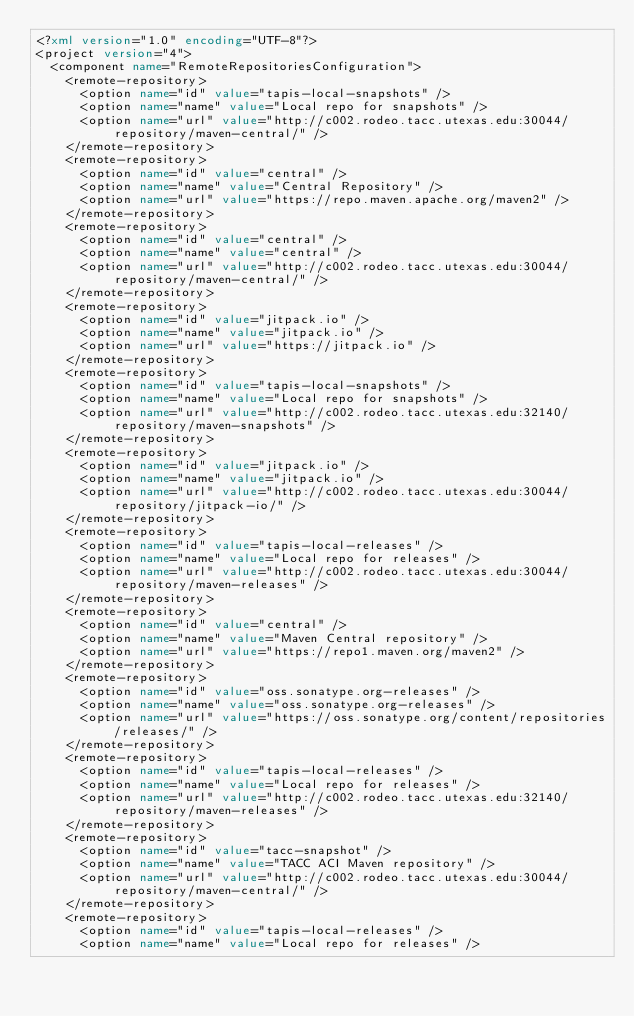Convert code to text. <code><loc_0><loc_0><loc_500><loc_500><_XML_><?xml version="1.0" encoding="UTF-8"?>
<project version="4">
  <component name="RemoteRepositoriesConfiguration">
    <remote-repository>
      <option name="id" value="tapis-local-snapshots" />
      <option name="name" value="Local repo for snapshots" />
      <option name="url" value="http://c002.rodeo.tacc.utexas.edu:30044/repository/maven-central/" />
    </remote-repository>
    <remote-repository>
      <option name="id" value="central" />
      <option name="name" value="Central Repository" />
      <option name="url" value="https://repo.maven.apache.org/maven2" />
    </remote-repository>
    <remote-repository>
      <option name="id" value="central" />
      <option name="name" value="central" />
      <option name="url" value="http://c002.rodeo.tacc.utexas.edu:30044/repository/maven-central/" />
    </remote-repository>
    <remote-repository>
      <option name="id" value="jitpack.io" />
      <option name="name" value="jitpack.io" />
      <option name="url" value="https://jitpack.io" />
    </remote-repository>
    <remote-repository>
      <option name="id" value="tapis-local-snapshots" />
      <option name="name" value="Local repo for snapshots" />
      <option name="url" value="http://c002.rodeo.tacc.utexas.edu:32140/repository/maven-snapshots" />
    </remote-repository>
    <remote-repository>
      <option name="id" value="jitpack.io" />
      <option name="name" value="jitpack.io" />
      <option name="url" value="http://c002.rodeo.tacc.utexas.edu:30044/repository/jitpack-io/" />
    </remote-repository>
    <remote-repository>
      <option name="id" value="tapis-local-releases" />
      <option name="name" value="Local repo for releases" />
      <option name="url" value="http://c002.rodeo.tacc.utexas.edu:30044/repository/maven-releases" />
    </remote-repository>
    <remote-repository>
      <option name="id" value="central" />
      <option name="name" value="Maven Central repository" />
      <option name="url" value="https://repo1.maven.org/maven2" />
    </remote-repository>
    <remote-repository>
      <option name="id" value="oss.sonatype.org-releases" />
      <option name="name" value="oss.sonatype.org-releases" />
      <option name="url" value="https://oss.sonatype.org/content/repositories/releases/" />
    </remote-repository>
    <remote-repository>
      <option name="id" value="tapis-local-releases" />
      <option name="name" value="Local repo for releases" />
      <option name="url" value="http://c002.rodeo.tacc.utexas.edu:32140/repository/maven-releases" />
    </remote-repository>
    <remote-repository>
      <option name="id" value="tacc-snapshot" />
      <option name="name" value="TACC ACI Maven repository" />
      <option name="url" value="http://c002.rodeo.tacc.utexas.edu:30044/repository/maven-central/" />
    </remote-repository>
    <remote-repository>
      <option name="id" value="tapis-local-releases" />
      <option name="name" value="Local repo for releases" /></code> 